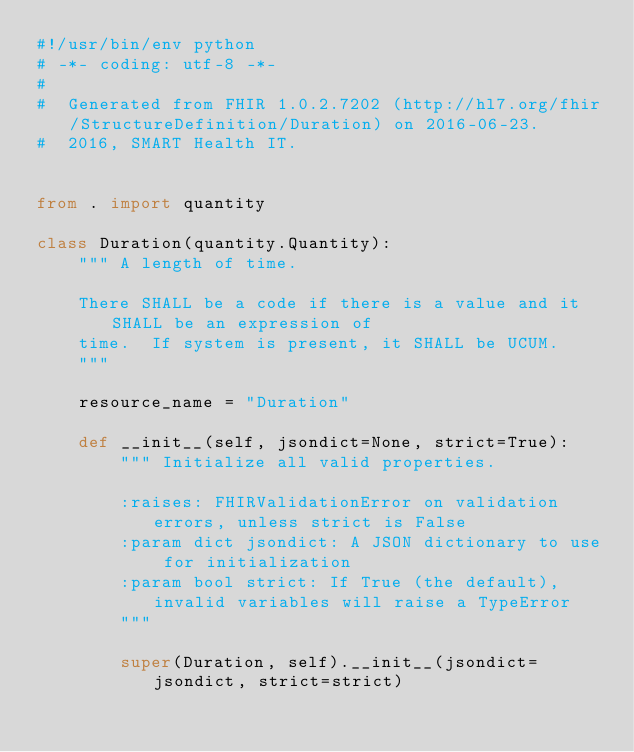<code> <loc_0><loc_0><loc_500><loc_500><_Python_>#!/usr/bin/env python
# -*- coding: utf-8 -*-
#
#  Generated from FHIR 1.0.2.7202 (http://hl7.org/fhir/StructureDefinition/Duration) on 2016-06-23.
#  2016, SMART Health IT.


from . import quantity

class Duration(quantity.Quantity):
    """ A length of time.
    
    There SHALL be a code if there is a value and it SHALL be an expression of
    time.  If system is present, it SHALL be UCUM.
    """
    
    resource_name = "Duration"
    
    def __init__(self, jsondict=None, strict=True):
        """ Initialize all valid properties.
        
        :raises: FHIRValidationError on validation errors, unless strict is False
        :param dict jsondict: A JSON dictionary to use for initialization
        :param bool strict: If True (the default), invalid variables will raise a TypeError
        """
        
        super(Duration, self).__init__(jsondict=jsondict, strict=strict)


</code> 